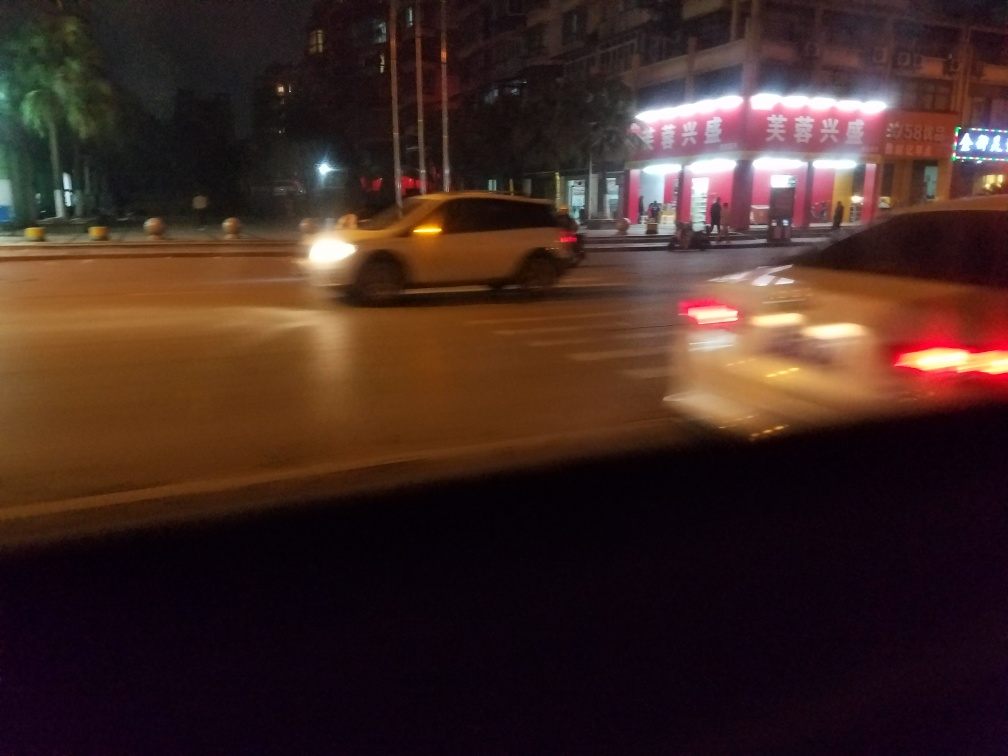Can you describe the atmosphere or mood that this image evokes? The image captures an urban night scene that is bustling with activity. The motion blur of the cars conveys a sense of movement and haste, while the lit signage provides a sense of the commercial aspect of the city. The mood appears rushed and dynamic, typical of city life at night. 